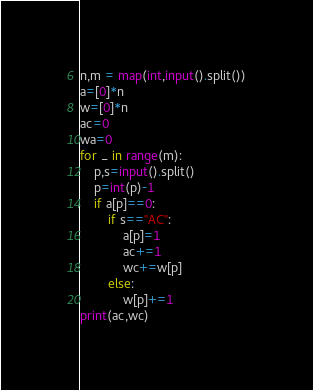<code> <loc_0><loc_0><loc_500><loc_500><_Python_>n,m = map(int,input().split())
a=[0]*n
w=[0]*n
ac=0
wa=0
for _ in range(m):
    p,s=input().split()
    p=int(p)-1
    if a[p]==0:
        if s=="AC":
            a[p]=1
            ac+=1
            wc+=w[p]
        else:
            w[p]+=1
print(ac,wc)</code> 